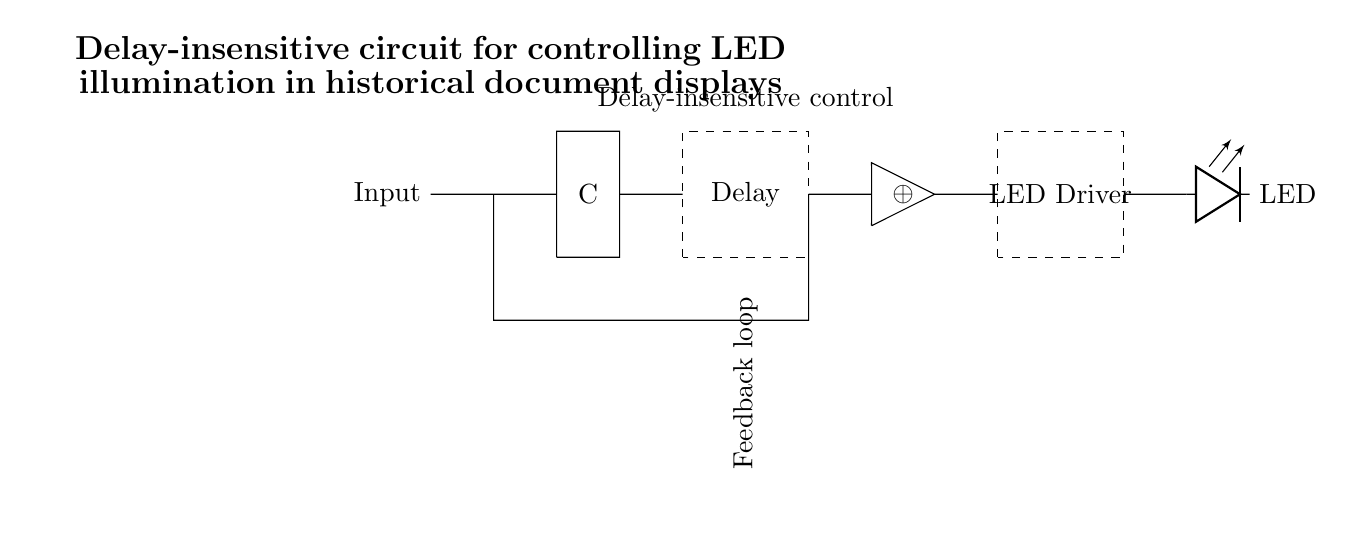What component provides the delay in this circuit? The delay is provided by the designated delay element, which is represented by a dashed rectangle labeled "Delay." This indicates the section of the circuit responsible for introducing a time delay.
Answer: Delay How many inputs does the Muller C-element have? The Muller C-element has two inputs, indicated by the two wires leading into the component marked "C" in the diagram. Each input contributes to the decision-making process of the C-element.
Answer: Two What is the output component of this circuit? The output is the LED, as shown by the component labeled "LED" in the circuit diagram. It is connected to the LED driver, which controls its illumination.
Answer: LED Which type of gate is used in this circuit? The type of gate used is an XOR gate, denoted by the symbol for XOR in the diagram. This gate performs a specific logical operation that is part of the circuit control.
Answer: XOR What is the purpose of the feedback loop in this circuit? The feedback loop allows the output state to influence the input, ensuring that the circuit can stabilize its output based on previous states or inputs. This maintains consistency in the operation of the Muller C-element.
Answer: Stabilization Which component drives the LED in this circuit? The component that drives the LED is the LED driver, indicated by a dashed rectangle labeled "LED Driver." This component provides the necessary current and control signal to illuminate the LED.
Answer: LED Driver 